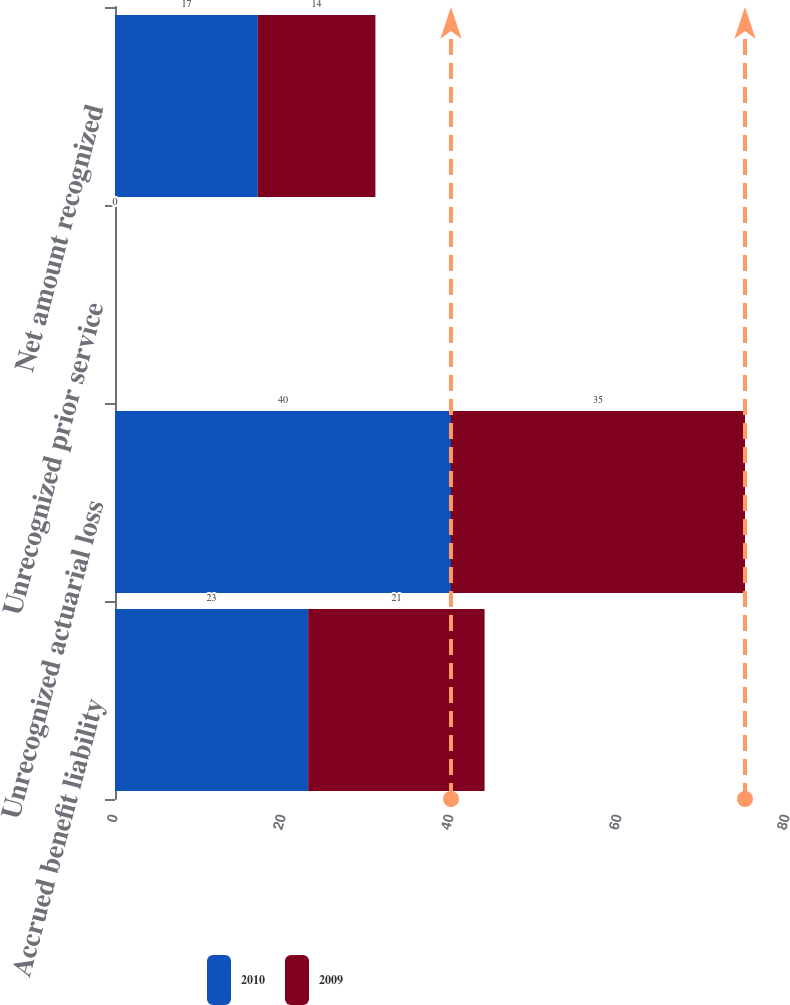Convert chart. <chart><loc_0><loc_0><loc_500><loc_500><stacked_bar_chart><ecel><fcel>Accrued benefit liability<fcel>Unrecognized actuarial loss<fcel>Unrecognized prior service<fcel>Net amount recognized<nl><fcel>2010<fcel>23<fcel>40<fcel>0<fcel>17<nl><fcel>2009<fcel>21<fcel>35<fcel>0<fcel>14<nl></chart> 